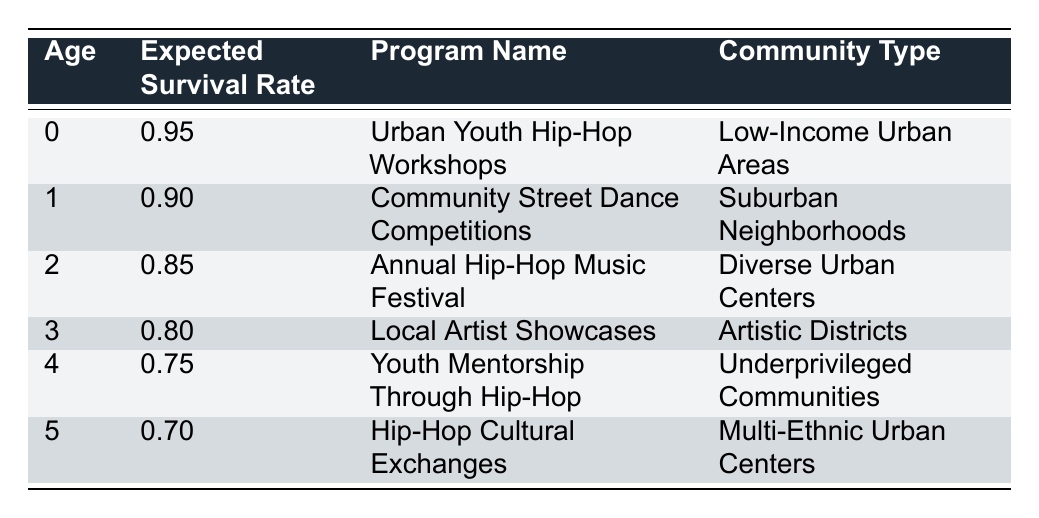What is the expected survival rate for the Urban Youth Hip-Hop Workshops at age 0? The table specifies the expected survival rate at age 0 for the program "Urban Youth Hip-Hop Workshops" as 0.95.
Answer: 0.95 Which program has the lowest expected survival rate? By examining the table, "Hip-Hop Cultural Exchanges" at age 5 shows the lowest expected survival rate of 0.70.
Answer: Hip-Hop Cultural Exchanges What is the expected survival rate for programs targeted at Low-Income Urban Areas? The only program listed for Low-Income Urban Areas is "Urban Youth Hip-Hop Workshops," which has an expected survival rate of 0.95.
Answer: 0.95 What is the average expected survival rate of programs for ages 0 to 4? The expected survival rates are 0.95, 0.90, 0.85, 0.80, and 0.75. To calculate the average, sum these: 0.95 + 0.90 + 0.85 + 0.80 + 0.75 = 4.25. Divide by 5 (the number of data points): 4.25 / 5 = 0.85.
Answer: 0.85 Is it true that the expected survival rate decreases as age increases across programs? By looking at the expected survival rates in the table, they start at 0.95 at age 0 and decrease to 0.70 at age 5, demonstrating a consistent decrease. Thus, the statement is true.
Answer: True Which community type has the program with the highest expected survival rate? The program with the highest expected survival rate is "Urban Youth Hip-Hop Workshops," with a rate of 0.95, and it is targeted at Low-Income Urban Areas. Therefore, Low-Income Urban Areas have the highest rate.
Answer: Low-Income Urban Areas What is the difference in expected survival rates between age 2 and age 5? The expected survival rate at age 2 (0.85) and age 5 (0.70) are compared by calculating 0.85 - 0.70 = 0.15. This shows a decrease of 0.15 from age 2 to age 5.
Answer: 0.15 Do any programs have an expected survival rate of 0.80 or above? Yes, "Urban Youth Hip-Hop Workshops" (0.95), "Community Street Dance Competitions" (0.90), "Annual Hip-Hop Music Festival" (0.85), and "Local Artist Showcases" (0.80) all have expected survival rates of 0.80 or above according to the table.
Answer: Yes What is the total expected survival rate of the programs for ages 1 to 3? The expected survival rates for ages 1, 2, and 3 are 0.90, 0.85, and 0.80 respectively. To find the total, sum these values: 0.90 + 0.85 + 0.80 = 2.55.
Answer: 2.55 